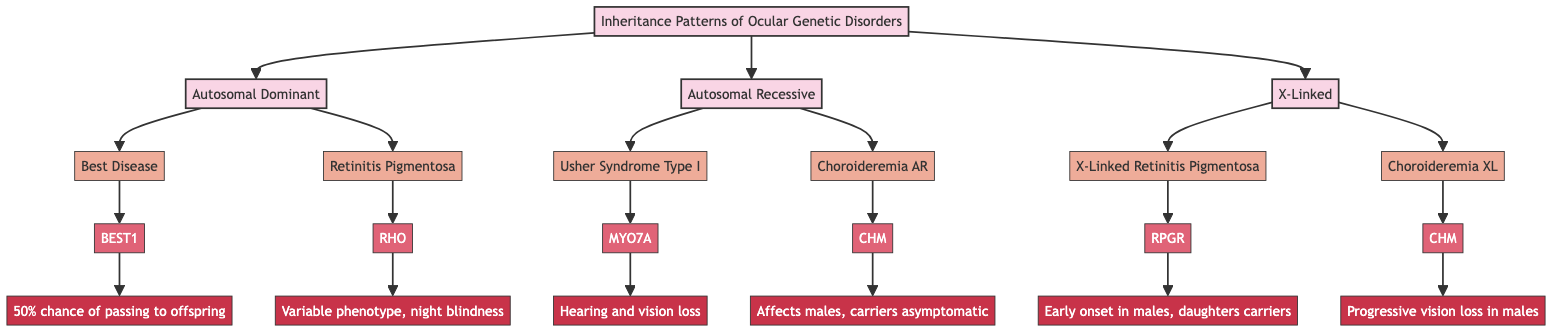What are the three main inheritance patterns illustrated in the diagram? The diagram explicitly shows three main inheritance patterns: Autosomal Dominant, Autosomal Recessive, and X-Linked. These are the first-level nodes branching out from the main title node.
Answer: Autosomal Dominant, Autosomal Recessive, X-Linked Which example disease is associated with the gene BEST1? The diagram indicates that Best Disease is associated with the gene BEST1, showing a direct connection from the disease node to the gene node.
Answer: Best Disease How many examples are provided for Autosomal Recessive inheritance? The diagram shows two examples listed under Autosomal Recessive: Usher Syndrome Type I and Choroideremia. Therefore, counting these gives us a total of two examples.
Answer: 2 What is the primary implication of X-Linked Retinitis Pigmentosa? The diagram mentions that the primary implication of X-Linked Retinitis Pigmentosa is that affected males exhibit symptoms earlier and that daughters of affected males are carriers. This information is directly linked to the disease node.
Answer: Early onset in males, daughters carriers Which gene is associated with Choroideremia, and how does this association differ between inheritance patterns? Choroideremia is associated with the gene CHM in both the Autosomal Recessive and X-Linked sections of the diagram. However, the implications differ: it affects males more severely in the X-Linked pattern but mentions carriers (females) are usually asymptomatic in the recessive pattern.
Answer: CHM; affects males in X-Linked, carriers asymptomatic in Autosomal Recessive 